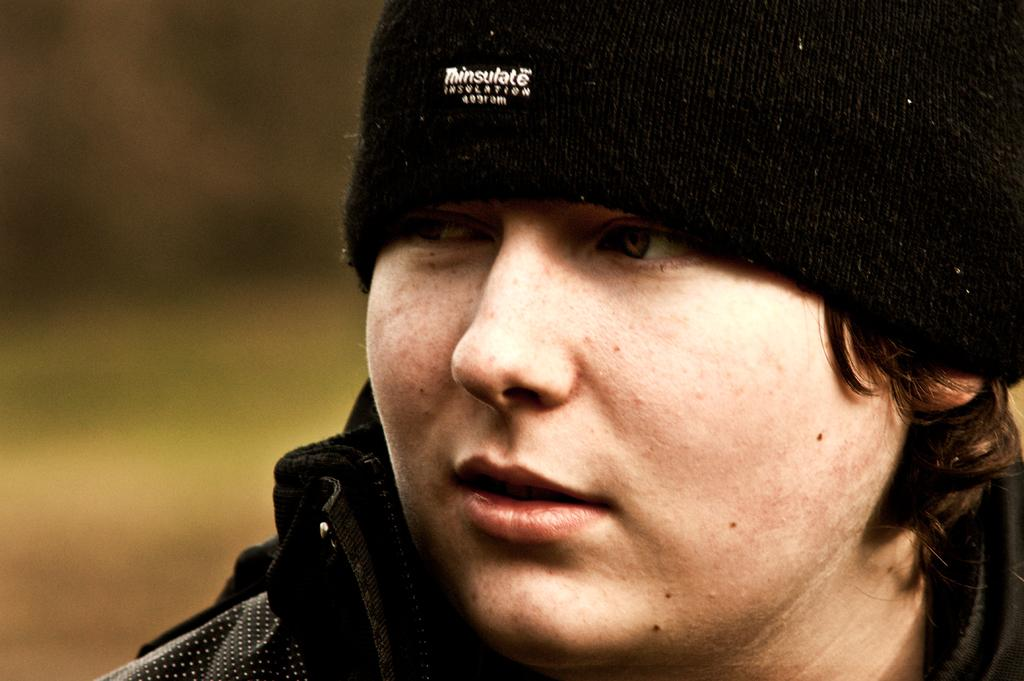Who or what is the main subject in the image? There is a person in the image. Can you describe the person's attire? The person is wearing a black cap. Is there any text or design on the cap? Yes, there is writing on the cap. What can be observed about the background of the image? The background of the image is blurred. What type of jail can be seen in the background of the image? There is no jail present in the image; the background is blurred. 